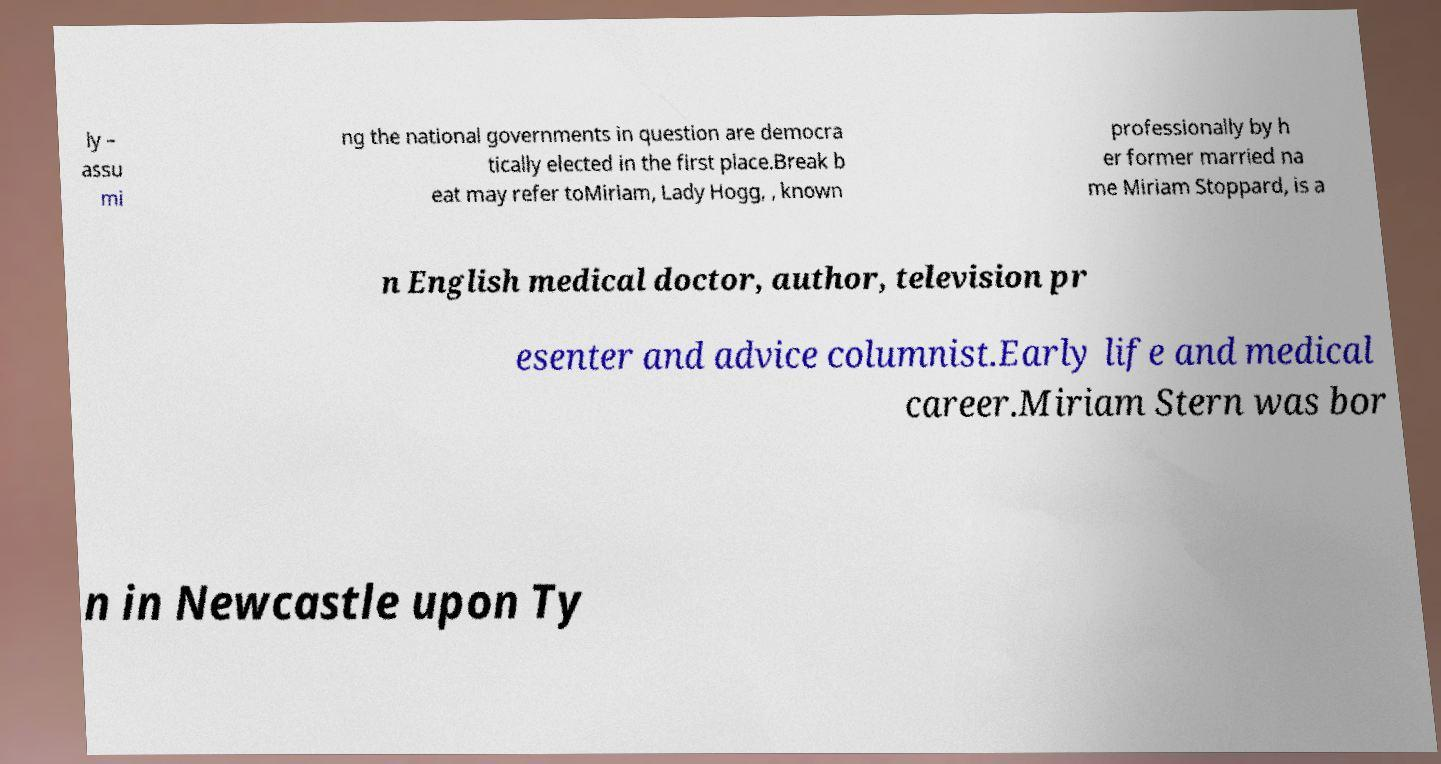Can you accurately transcribe the text from the provided image for me? ly – assu mi ng the national governments in question are democra tically elected in the first place.Break b eat may refer toMiriam, Lady Hogg, , known professionally by h er former married na me Miriam Stoppard, is a n English medical doctor, author, television pr esenter and advice columnist.Early life and medical career.Miriam Stern was bor n in Newcastle upon Ty 